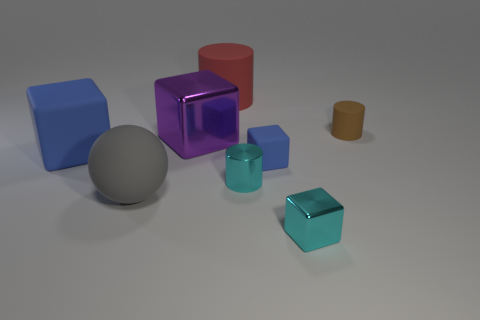What materials do the objects in the image appear to be made of? The objects in the image seem to be made from various materials that could include plastic, rubber, or even glass, given their smooth textures and light-reflecting surfaces. 